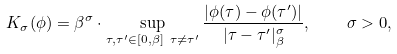<formula> <loc_0><loc_0><loc_500><loc_500>K _ { \sigma } ( \phi ) = \beta ^ { \sigma } \cdot \sup _ { \tau , \tau ^ { \prime } \in [ 0 , \beta ] \ \tau \neq \tau ^ { \prime } } \frac { | \phi ( \tau ) - \phi ( \tau ^ { \prime } ) | } { | \tau - \tau ^ { \prime } | ^ { \sigma } _ { \beta } } , \quad \sigma > 0 ,</formula> 